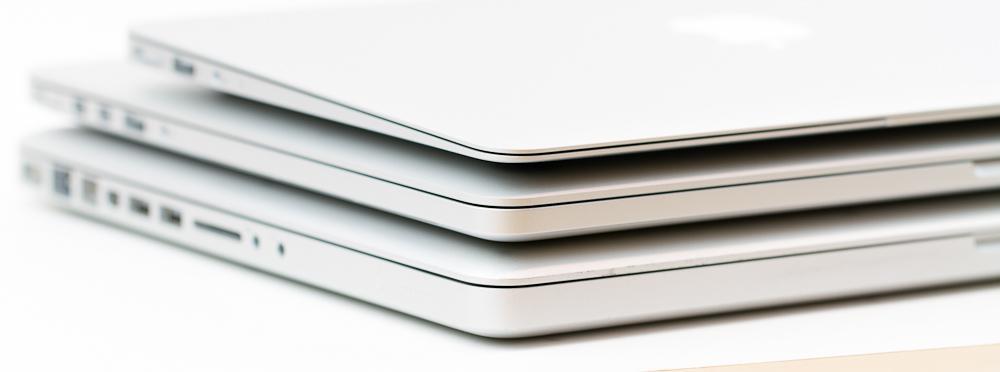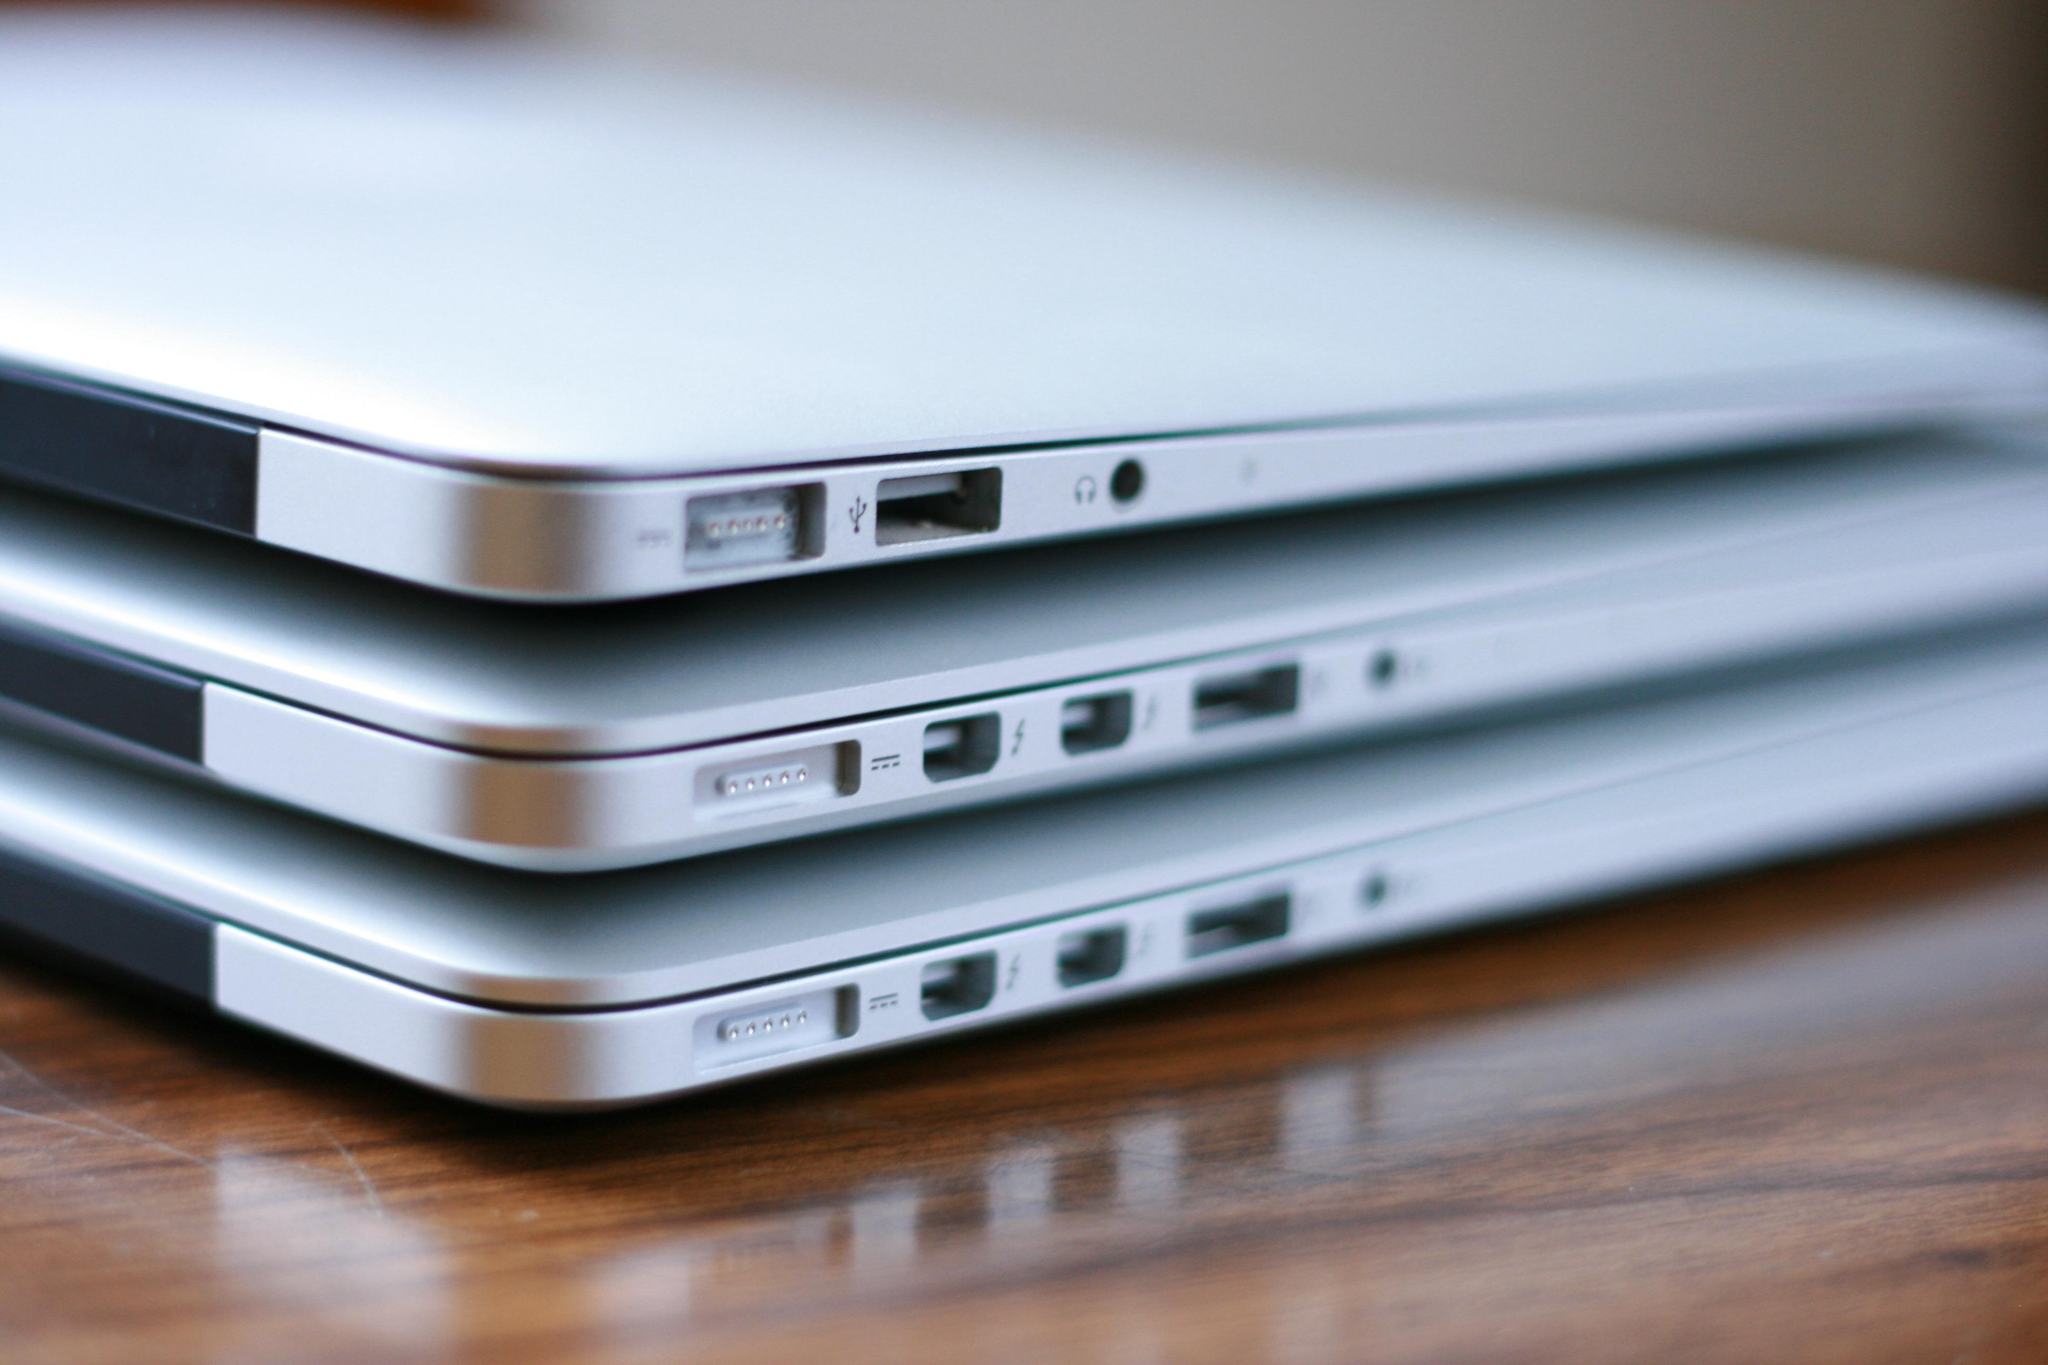The first image is the image on the left, the second image is the image on the right. For the images shown, is this caption "In the image to the right, several electronic objects are stacked on top of each other." true? Answer yes or no. Yes. The first image is the image on the left, the second image is the image on the right. For the images displayed, is the sentence "The left image shows a neat stack of at least three white laptop-type devices." factually correct? Answer yes or no. Yes. 